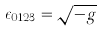Convert formula to latex. <formula><loc_0><loc_0><loc_500><loc_500>\epsilon _ { 0 1 2 3 } = \sqrt { - g }</formula> 